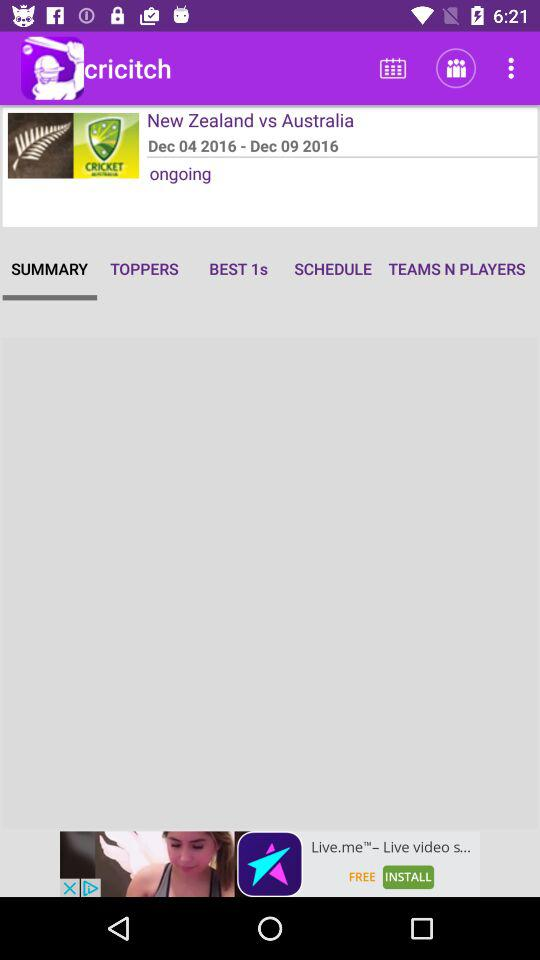How many days long is the match?
Answer the question using a single word or phrase. 6 